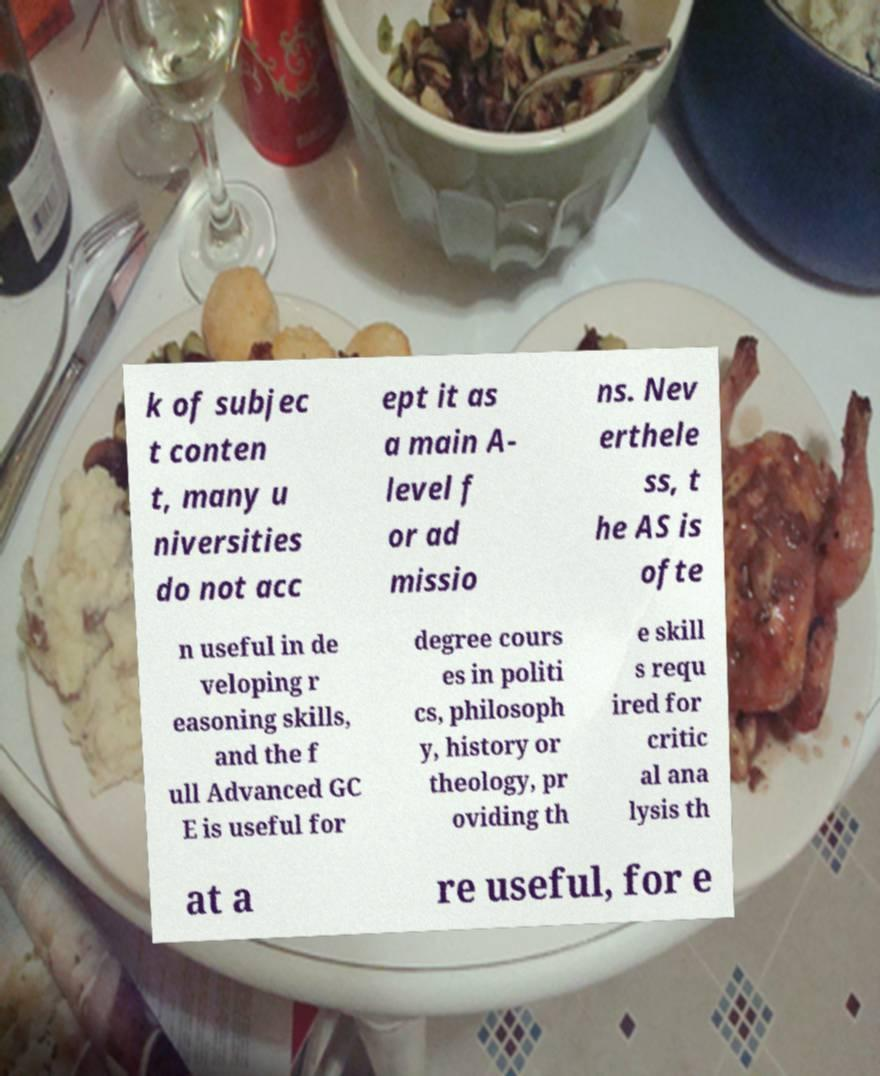Please read and relay the text visible in this image. What does it say? k of subjec t conten t, many u niversities do not acc ept it as a main A- level f or ad missio ns. Nev erthele ss, t he AS is ofte n useful in de veloping r easoning skills, and the f ull Advanced GC E is useful for degree cours es in politi cs, philosoph y, history or theology, pr oviding th e skill s requ ired for critic al ana lysis th at a re useful, for e 